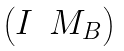<formula> <loc_0><loc_0><loc_500><loc_500>\begin{pmatrix} I & M _ { B } \end{pmatrix}</formula> 